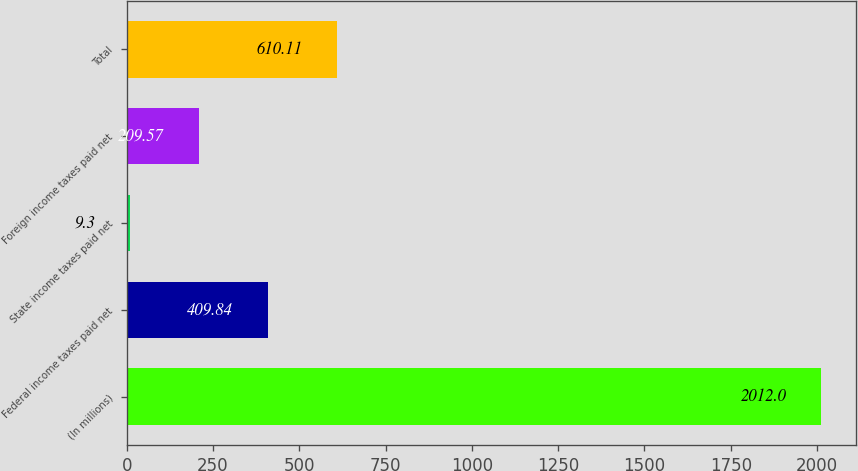<chart> <loc_0><loc_0><loc_500><loc_500><bar_chart><fcel>(In millions)<fcel>Federal income taxes paid net<fcel>State income taxes paid net<fcel>Foreign income taxes paid net<fcel>Total<nl><fcel>2012<fcel>409.84<fcel>9.3<fcel>209.57<fcel>610.11<nl></chart> 